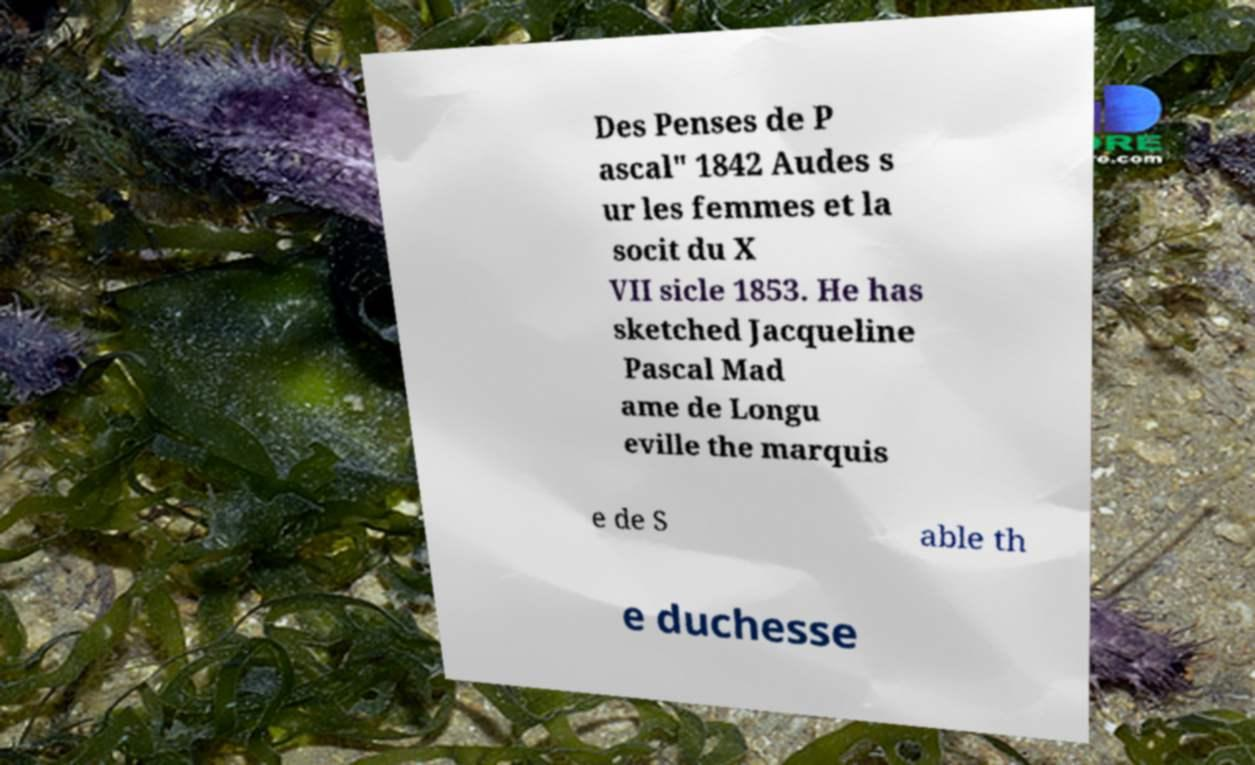For documentation purposes, I need the text within this image transcribed. Could you provide that? Des Penses de P ascal" 1842 Audes s ur les femmes et la socit du X VII sicle 1853. He has sketched Jacqueline Pascal Mad ame de Longu eville the marquis e de S able th e duchesse 